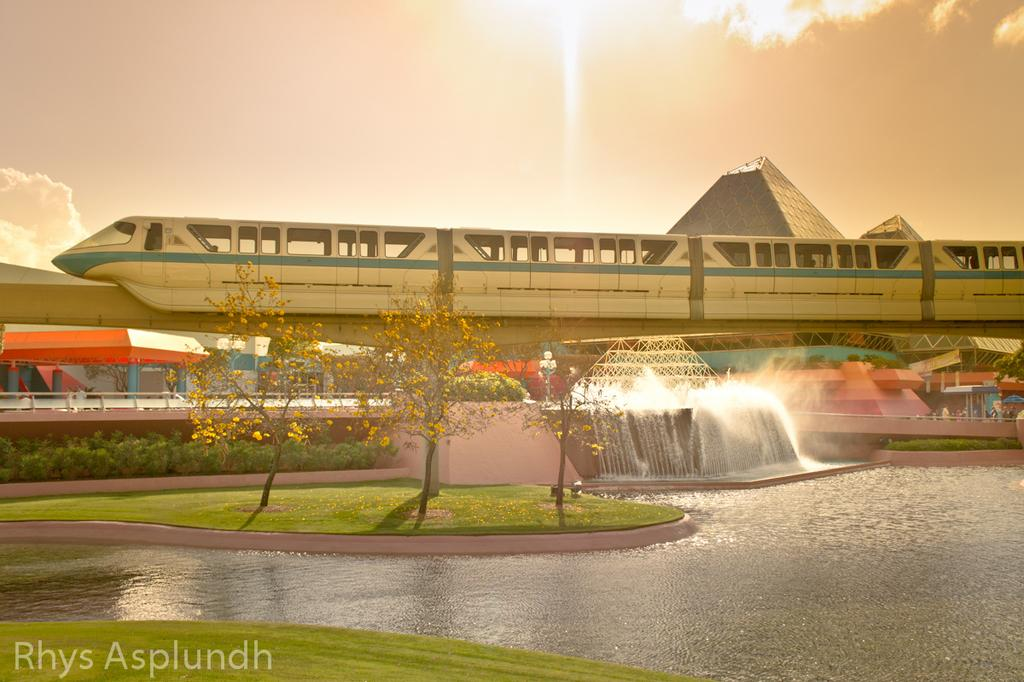What type of vegetation can be seen in the image? There is grass in the image. What natural element is also present in the image? There is water in the image. What other type of vegetation can be seen in the image? There are trees in the image. What man-made structure is present in the image? There is a bridge in the image. What mode of transportation can be seen in the image? There is a train in the image. What type of structures can be seen in the background of the image? There are buildings in the background of the image. What can be seen in the sky in the image? There are clouds in the sky. Can you tell me how many sinks are visible in the image? There are no sinks present in the image. What type of cabbage is growing on the bridge in the image? There is no cabbage present in the image, and the bridge is not a place where plants typically grow. 